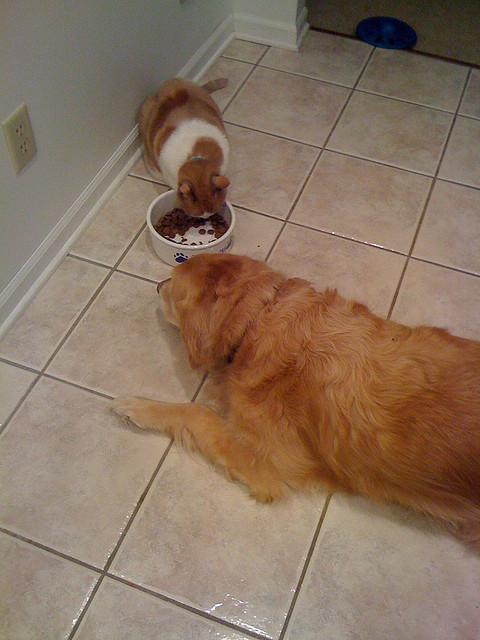Is the dog eating?
Concise answer only. No. What pattern is on the floor beneath the dogs?
Be succinct. Square. Which animal is eating out of the bowl?
Answer briefly. Cat. Is this a cat's normal  diet?
Concise answer only. Yes. What color is the dog?
Write a very short answer. Brown. 